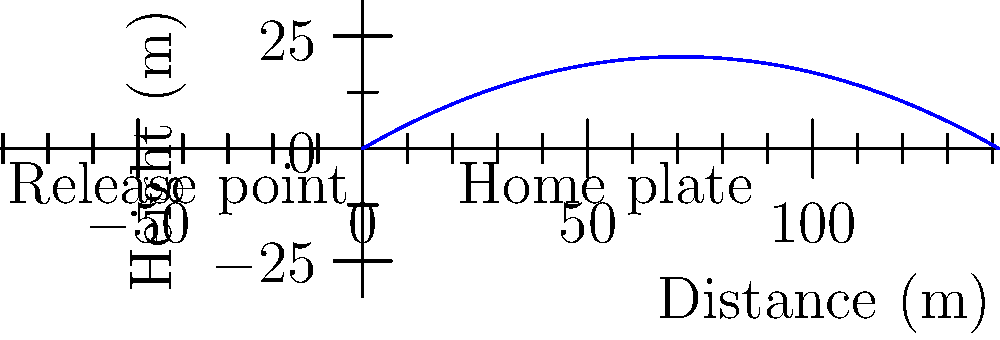A baseball pitcher throws a fastball with an initial velocity of 40 m/s at an angle of 30° above the horizontal. Assuming air resistance is negligible, what is the maximum height reached by the baseball during its trajectory to home plate, which is 18.44 meters away? Express your answer in terms of bits required to represent the height with millimeter precision. To solve this problem, we'll follow these steps:

1) First, we need to calculate the maximum height reached by the baseball. The equation for the maximum height of a projectile is:

   $$h_{max} = \frac{v_0^2 \sin^2 \theta}{2g}$$

   where $v_0$ is the initial velocity, $\theta$ is the launch angle, and $g$ is the acceleration due to gravity.

2) Plugging in our values:
   $v_0 = 40$ m/s
   $\theta = 30° = \pi/6$ radians
   $g = 9.8$ m/s²

   $$h_{max} = \frac{(40)^2 \sin^2 (\pi/6)}{2(9.8)} = 5.1 \text{ m}$$

3) Now, we need to determine how many bits are required to represent this height with millimeter precision.

4) To represent a height of 5.1 m with millimeter precision, we need to be able to represent 5100 discrete values (5.1 m = 5100 mm).

5) The number of bits required to represent $n$ discrete values is $\log_2(n)$, rounded up to the nearest integer.

6) In this case:
   $$\text{bits required} = \lceil \log_2(5100) \rceil = \lceil 12.3178... \rceil = 13$$

Therefore, 13 bits are required to represent the maximum height with millimeter precision.
Answer: 13 bits 